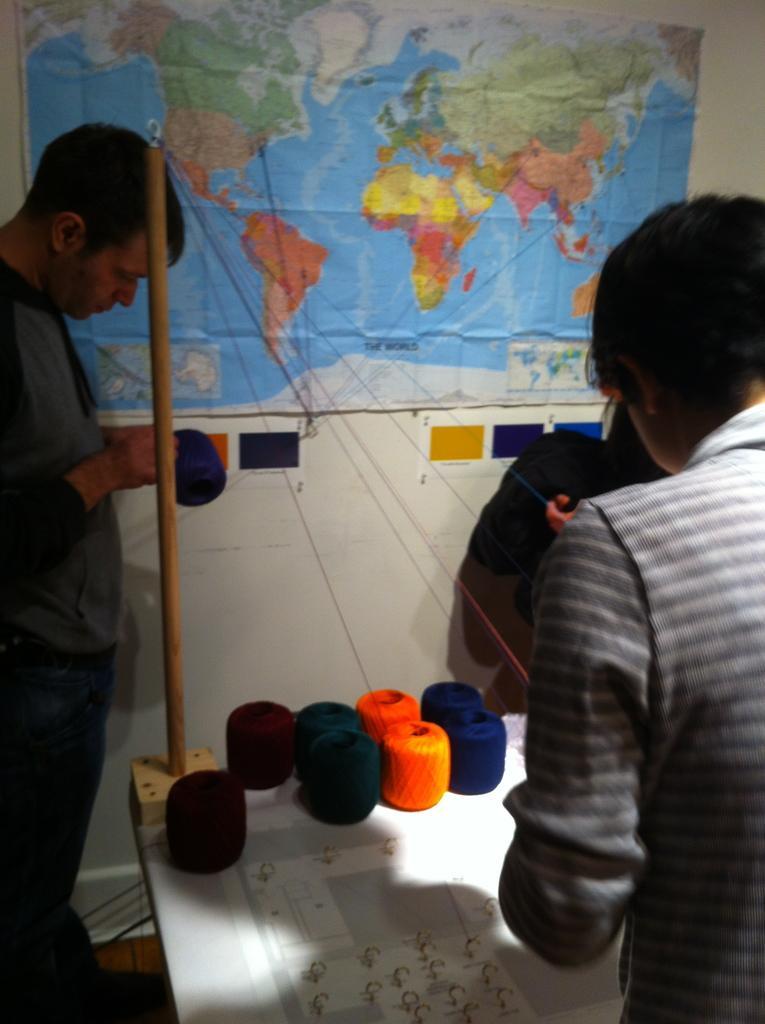Please provide a concise description of this image. In this picture I can observe thread rolls placed on the table. I can observe two members in this picture. In the background I can observe world map on the wall. 